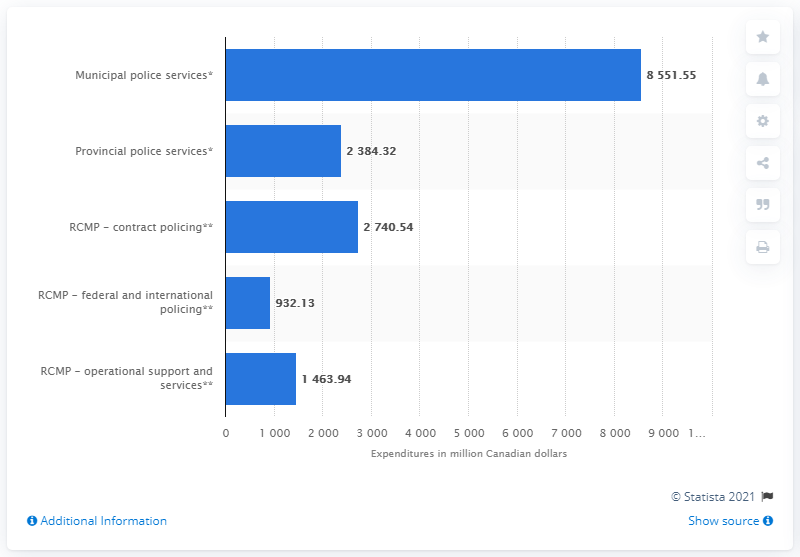Give some essential details in this illustration. The amount of money spent on contract policing for the Royal Canadian Mounted Police in the year 2018/19 was $27,40.54. 